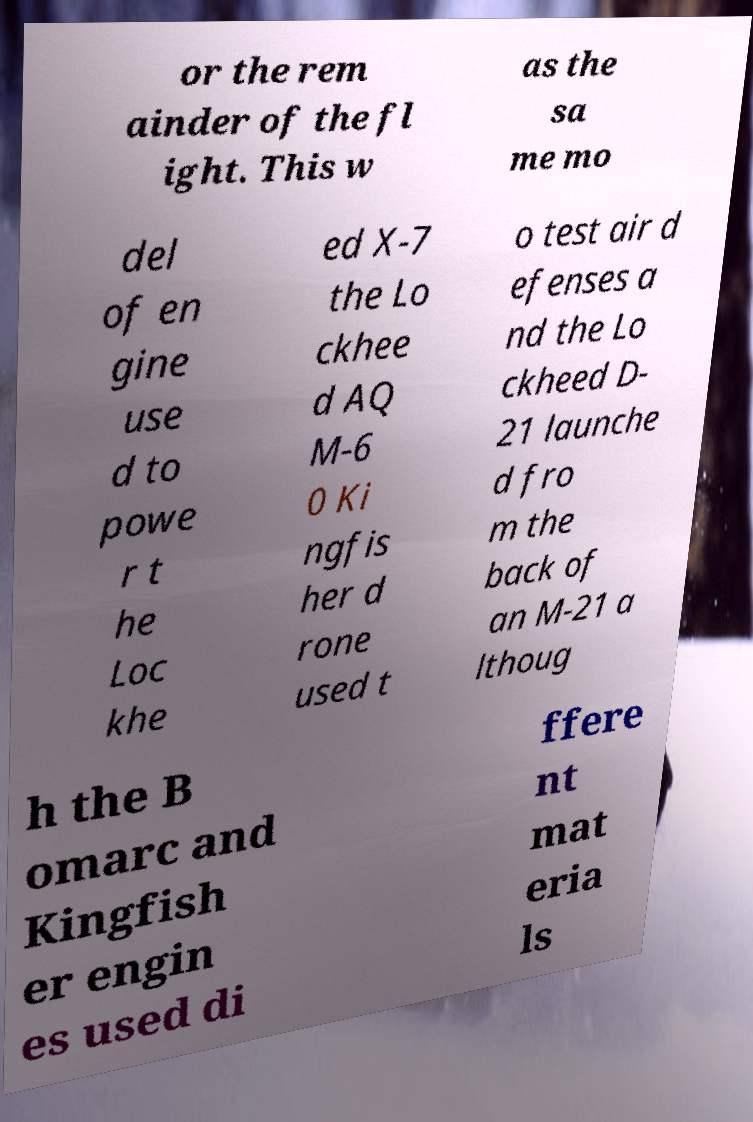What messages or text are displayed in this image? I need them in a readable, typed format. or the rem ainder of the fl ight. This w as the sa me mo del of en gine use d to powe r t he Loc khe ed X-7 the Lo ckhee d AQ M-6 0 Ki ngfis her d rone used t o test air d efenses a nd the Lo ckheed D- 21 launche d fro m the back of an M-21 a lthoug h the B omarc and Kingfish er engin es used di ffere nt mat eria ls 